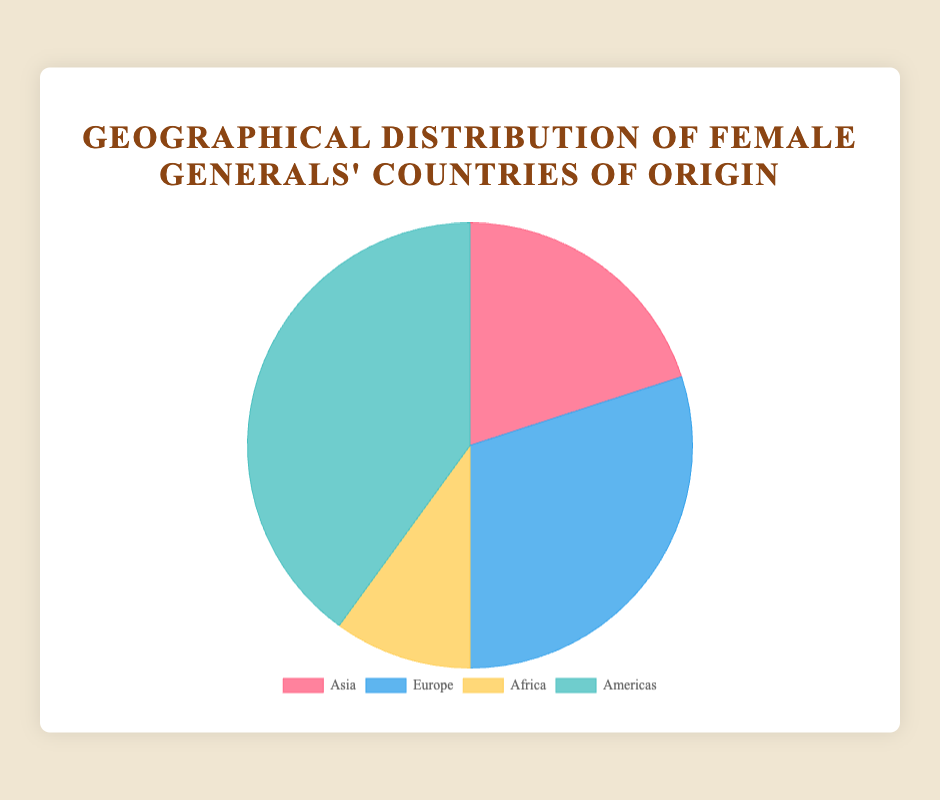What's the percentage of female generals from Asia? On the pie chart, Asia represents one of the sections. To find the percentage, use the value for Asia (20) and divide it by the total number of female generals (20 + 30 + 10 + 40). This gives 20 / 100 = 0.2, which is 20%.
Answer: 20% Which continent has the highest representation of female generals? The pie chart shows the numbers for each continent: Asia (20), Europe (30), Africa (10), Americas (40). The Americas sector is the largest with 40 female generals, which is the highest representation.
Answer: Americas How many more female generals are there in Europe compared to Africa? From the pie chart, Europe has 30 female generals and Africa has 10. The difference is 30 - 10.
Answer: 20 What's the total number of female generals represented in the chart? Sum the values of all the segments in the pie chart: 20 (Asia) + 30 (Europe) + 10 (Africa) + 40 (Americas) = 100.
Answer: 100 If another region had 10 female generals, how would this change the proportion of Africa? Currently, Africa has 10 out of 100 female generals which is 10%. Adding another region with 10 would make the total 110. The new percentage would be (10 / 110) * 100 = 9.09%.
Answer: 9.09% What is the average number of female generals per continent? The total number of female generals is 100, and there are four continents. So, the average is 100 / 4.
Answer: 25 How does the representation of female generals in Asia compare with the Americas? Asia has 20 female generals, while the Americas have 40. The Americas have twice as many as Asia.
Answer: Americas have twice as many What percentage do Asia and Europe together represent? Firstly, sum the values for Asia (20) and Europe (30) to get 50. Then divide by the total number (100) and multiply by 100. This gives (50 / 100) * 100 = 50%.
Answer: 50% Which region has the smallest representation, and what percentage is it? According to the pie chart, Africa has the smallest representation with 10 female generals. The percentage is (10 / 100) * 100, which equals 10%.
Answer: Africa, 10% What's the ratio of female generals from the Americas to those from Africa? The number of female generals in the Americas is 40, and in Africa, it is 10. The ratio is 40:10, which can be simplified to 4:1.
Answer: 4:1 